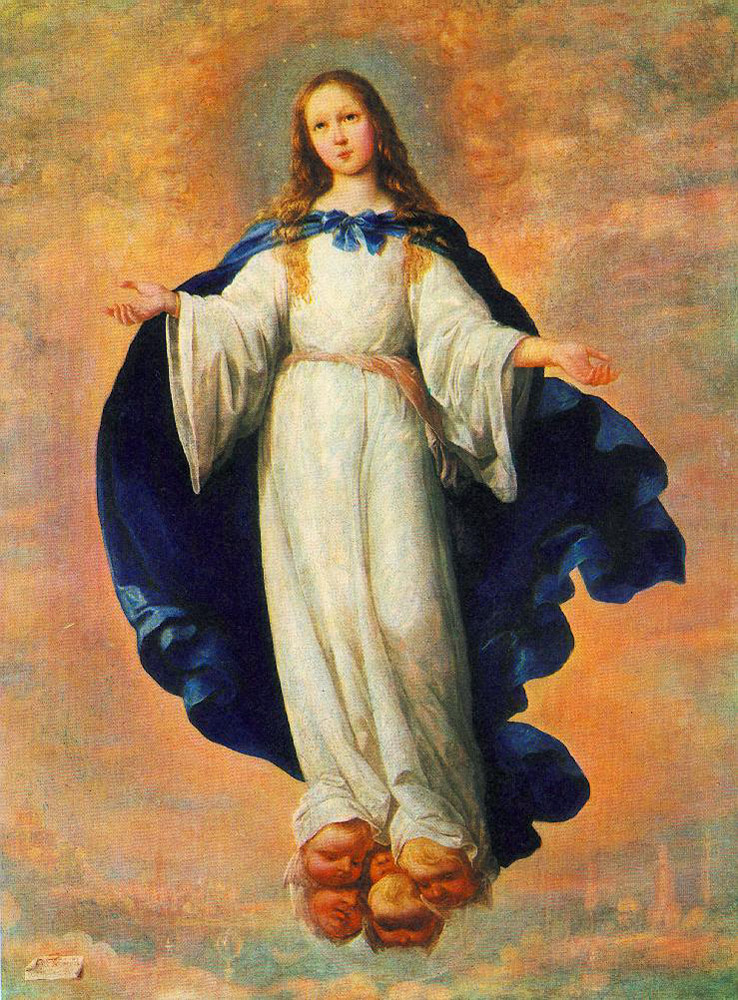What do you think is going on in this snapshot?
 The image portrays a young girl, adorned in a white dress and a blue cloak, suspended in the sky. Her long blonde hair cascades down her shoulders, and she gazes directly at the viewer, creating a sense of connection. The backdrop is a cloudy sky, beneath which lies a cityscape, adding depth to the scene. The art style leans towards realism, capturing intricate details and nuances. The genre of the artwork is religious, suggested by the ethereal quality of the girl's floating figure and the celestial setting. 